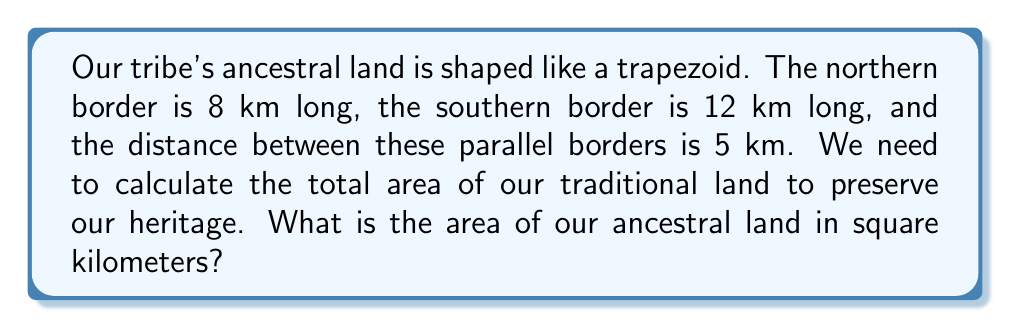Help me with this question. To solve this problem, we'll use the formula for the area of a trapezoid:

$$A = \frac{1}{2}(b_1 + b_2)h$$

Where:
$A$ = Area
$b_1$ = Length of one parallel side
$b_2$ = Length of the other parallel side
$h$ = Height (distance between the parallel sides)

Given:
$b_1 = 8$ km (northern border)
$b_2 = 12$ km (southern border)
$h = 5$ km (distance between borders)

Let's substitute these values into the formula:

$$A = \frac{1}{2}(8 + 12) \times 5$$

First, add the parallel sides:
$$A = \frac{1}{2}(20) \times 5$$

Now multiply:
$$A = 10 \times 5 = 50$$

Therefore, the area of the ancestral land is 50 square kilometers.

[asy]
unitsize(0.5cm);
pair A = (0,0), B = (12,0), C = (9,5), D = (-3,5);
draw(A--B--C--D--cycle);
label("12 km", (6,-0.5));
label("8 km", (3,5.5));
label("5 km", (12.5,2.5));
draw((12,0)--(12,5),dashed);
[/asy]
Answer: The area of the ancestral land is 50 square kilometers. 